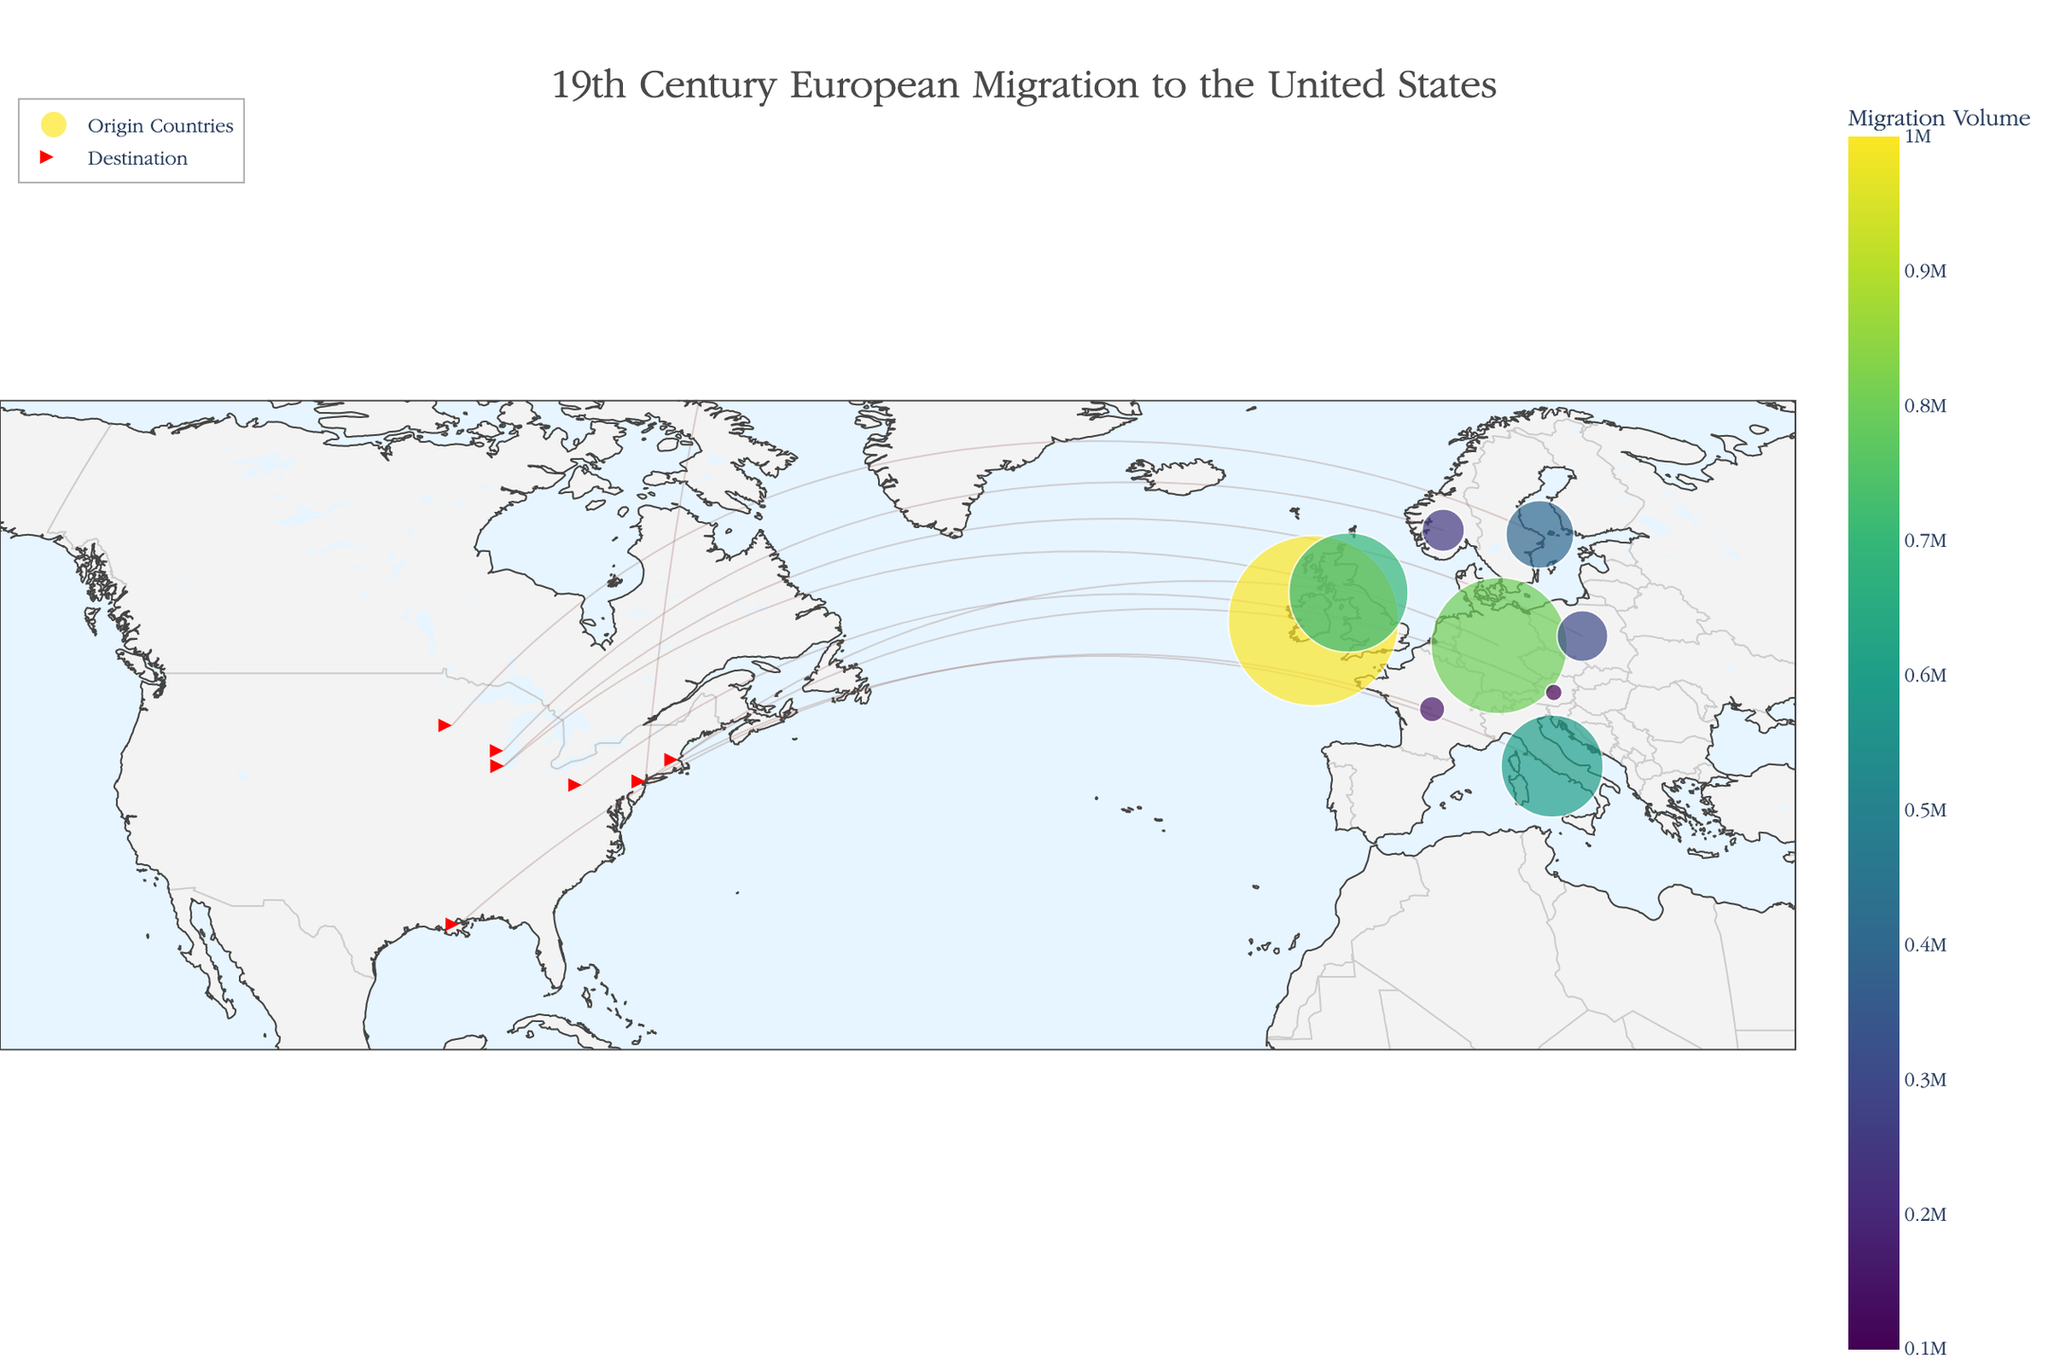Is there a title for the figure? The title of the figure is displayed at the top center of the plot, which helps to understand the overall context of the visualized data.
Answer: Yes, "19th Century European Migration to the United States" What color scale is used to represent migration volume? The color scale for migration volume is shown in the legend on the right side of the plot, represented by varying shades. The colors range typically indicate the volume of migration from different countries.
Answer: Viridis Which country had the highest volume of migration to the United States? By examining the size of the markers and the color scale on the figure, the largest marker indicates the highest volume of migration.
Answer: Ireland How do the migration volumes from Germany and Italy compare? To compare the migration volumes from Germany and Italy, locate the markers for these countries and observe their sizes and colors according to the color scale. Germany has a larger volume than Italy, as indicated by a larger marker and a more intense color.
Answer: Germany's volume is greater than Italy's volume Which destination in the United States received the highest migration volume? Identify end markers that represent destinations in the United States, and compare the sizes of the markers pointing to each city. The largest marker indicates the city that received the highest migration volume.
Answer: New York City How does the migration volume from Poland compare to that from Norway? Locate the markers for Poland and Norway and observe their sizes and colors. By the size and color intensity, Poland has a larger migration volume compared to Norway.
Answer: Poland's volume is greater than Norway's volume What is the average volume of migration from the countries listed? To find the average volume, add up the volumes for all countries (1,000,000 + 800,000 + 600,000 + 400,000 + 300,000 + 250,000 + 700,000 + 200,000 + 150,000 + 100,000) and divide by the number of countries (10). The sum is 4,500,000, and the average is 4,500,000 / 10.
Answer: 450,000 Which country from Scandinavia had a higher migration volume to the United States? Compare the Scandinavian countries (Sweden and Norway) by looking at the sizes and colors of the markers. Sweden has a larger migration volume shown by a bigger marker and a more intense color.
Answer: Sweden What is the total migration volume from all the countries listed? To calculate the total migration volume, sum up the volumes for all countries provided in the data. The volumes are: 1,000,000 (Ireland) + 800,000 (Germany) + 600,000 (Italy) + 400,000 (Sweden) + 300,000 (Poland) + 250,000 (Norway) + 700,000 (UK) + 200,000 (Russia) + 150,000 (France) + 100,000 (Austria). The total sum is 4,500,000.
Answer: 4,500,000 